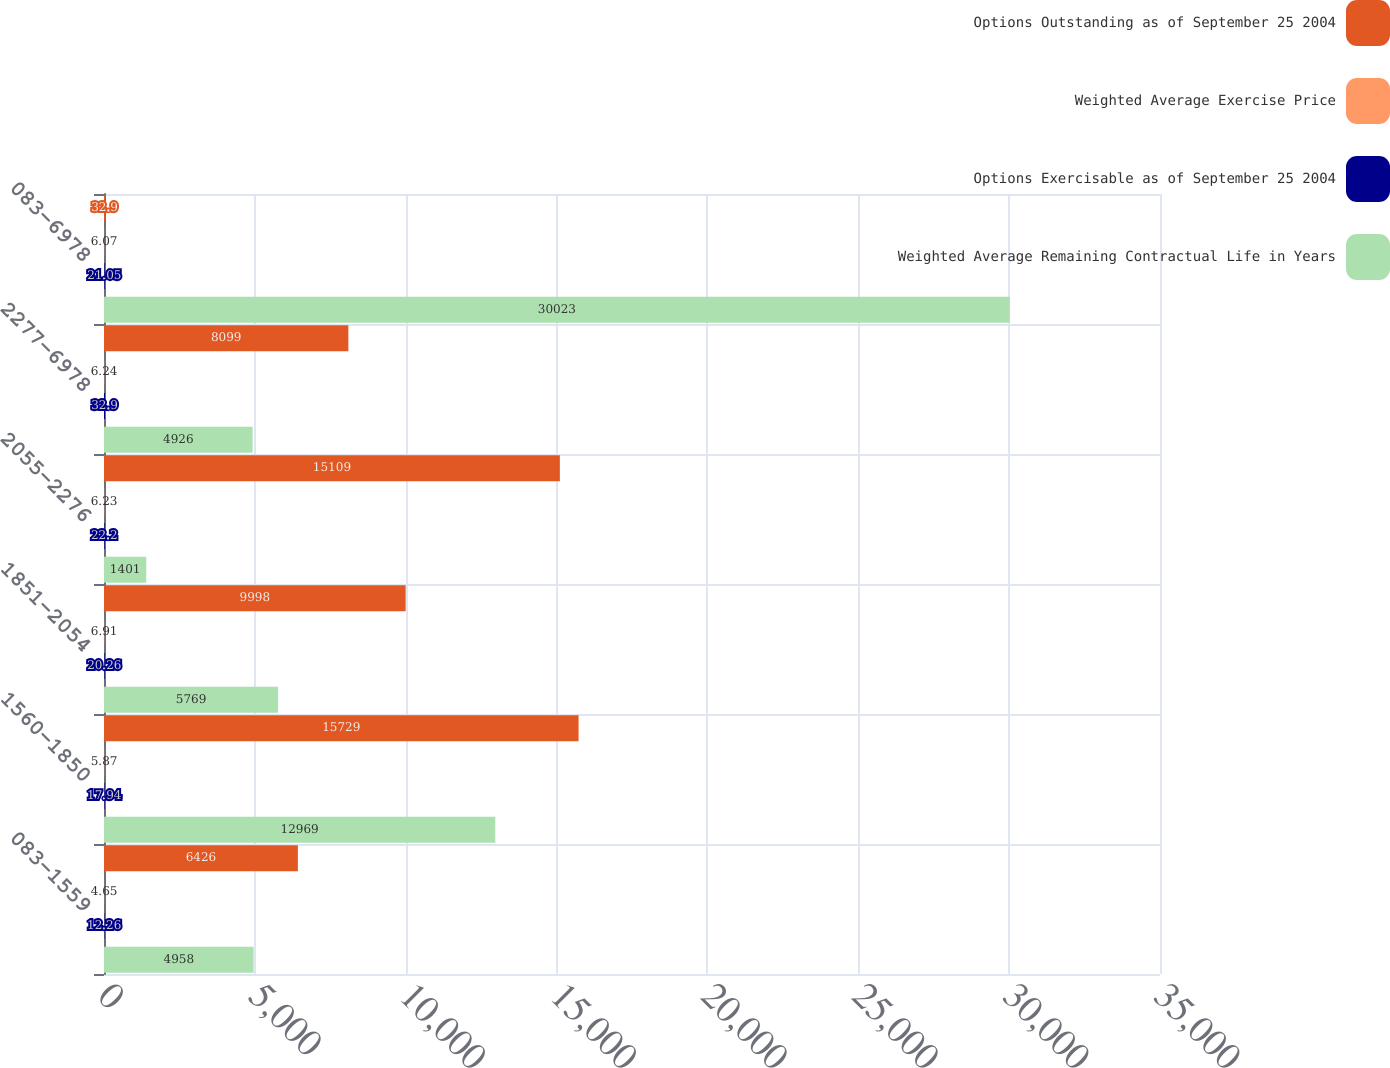Convert chart to OTSL. <chart><loc_0><loc_0><loc_500><loc_500><stacked_bar_chart><ecel><fcel>083-1559<fcel>1560-1850<fcel>1851-2054<fcel>2055-2276<fcel>2277-6978<fcel>083-6978<nl><fcel>Options Outstanding as of September 25 2004<fcel>6426<fcel>15729<fcel>9998<fcel>15109<fcel>8099<fcel>32.9<nl><fcel>Weighted Average Exercise Price<fcel>4.65<fcel>5.87<fcel>6.91<fcel>6.23<fcel>6.24<fcel>6.07<nl><fcel>Options Exercisable as of September 25 2004<fcel>12.26<fcel>17.94<fcel>20.26<fcel>22.2<fcel>32.9<fcel>21.05<nl><fcel>Weighted Average Remaining Contractual Life in Years<fcel>4958<fcel>12969<fcel>5769<fcel>1401<fcel>4926<fcel>30023<nl></chart> 